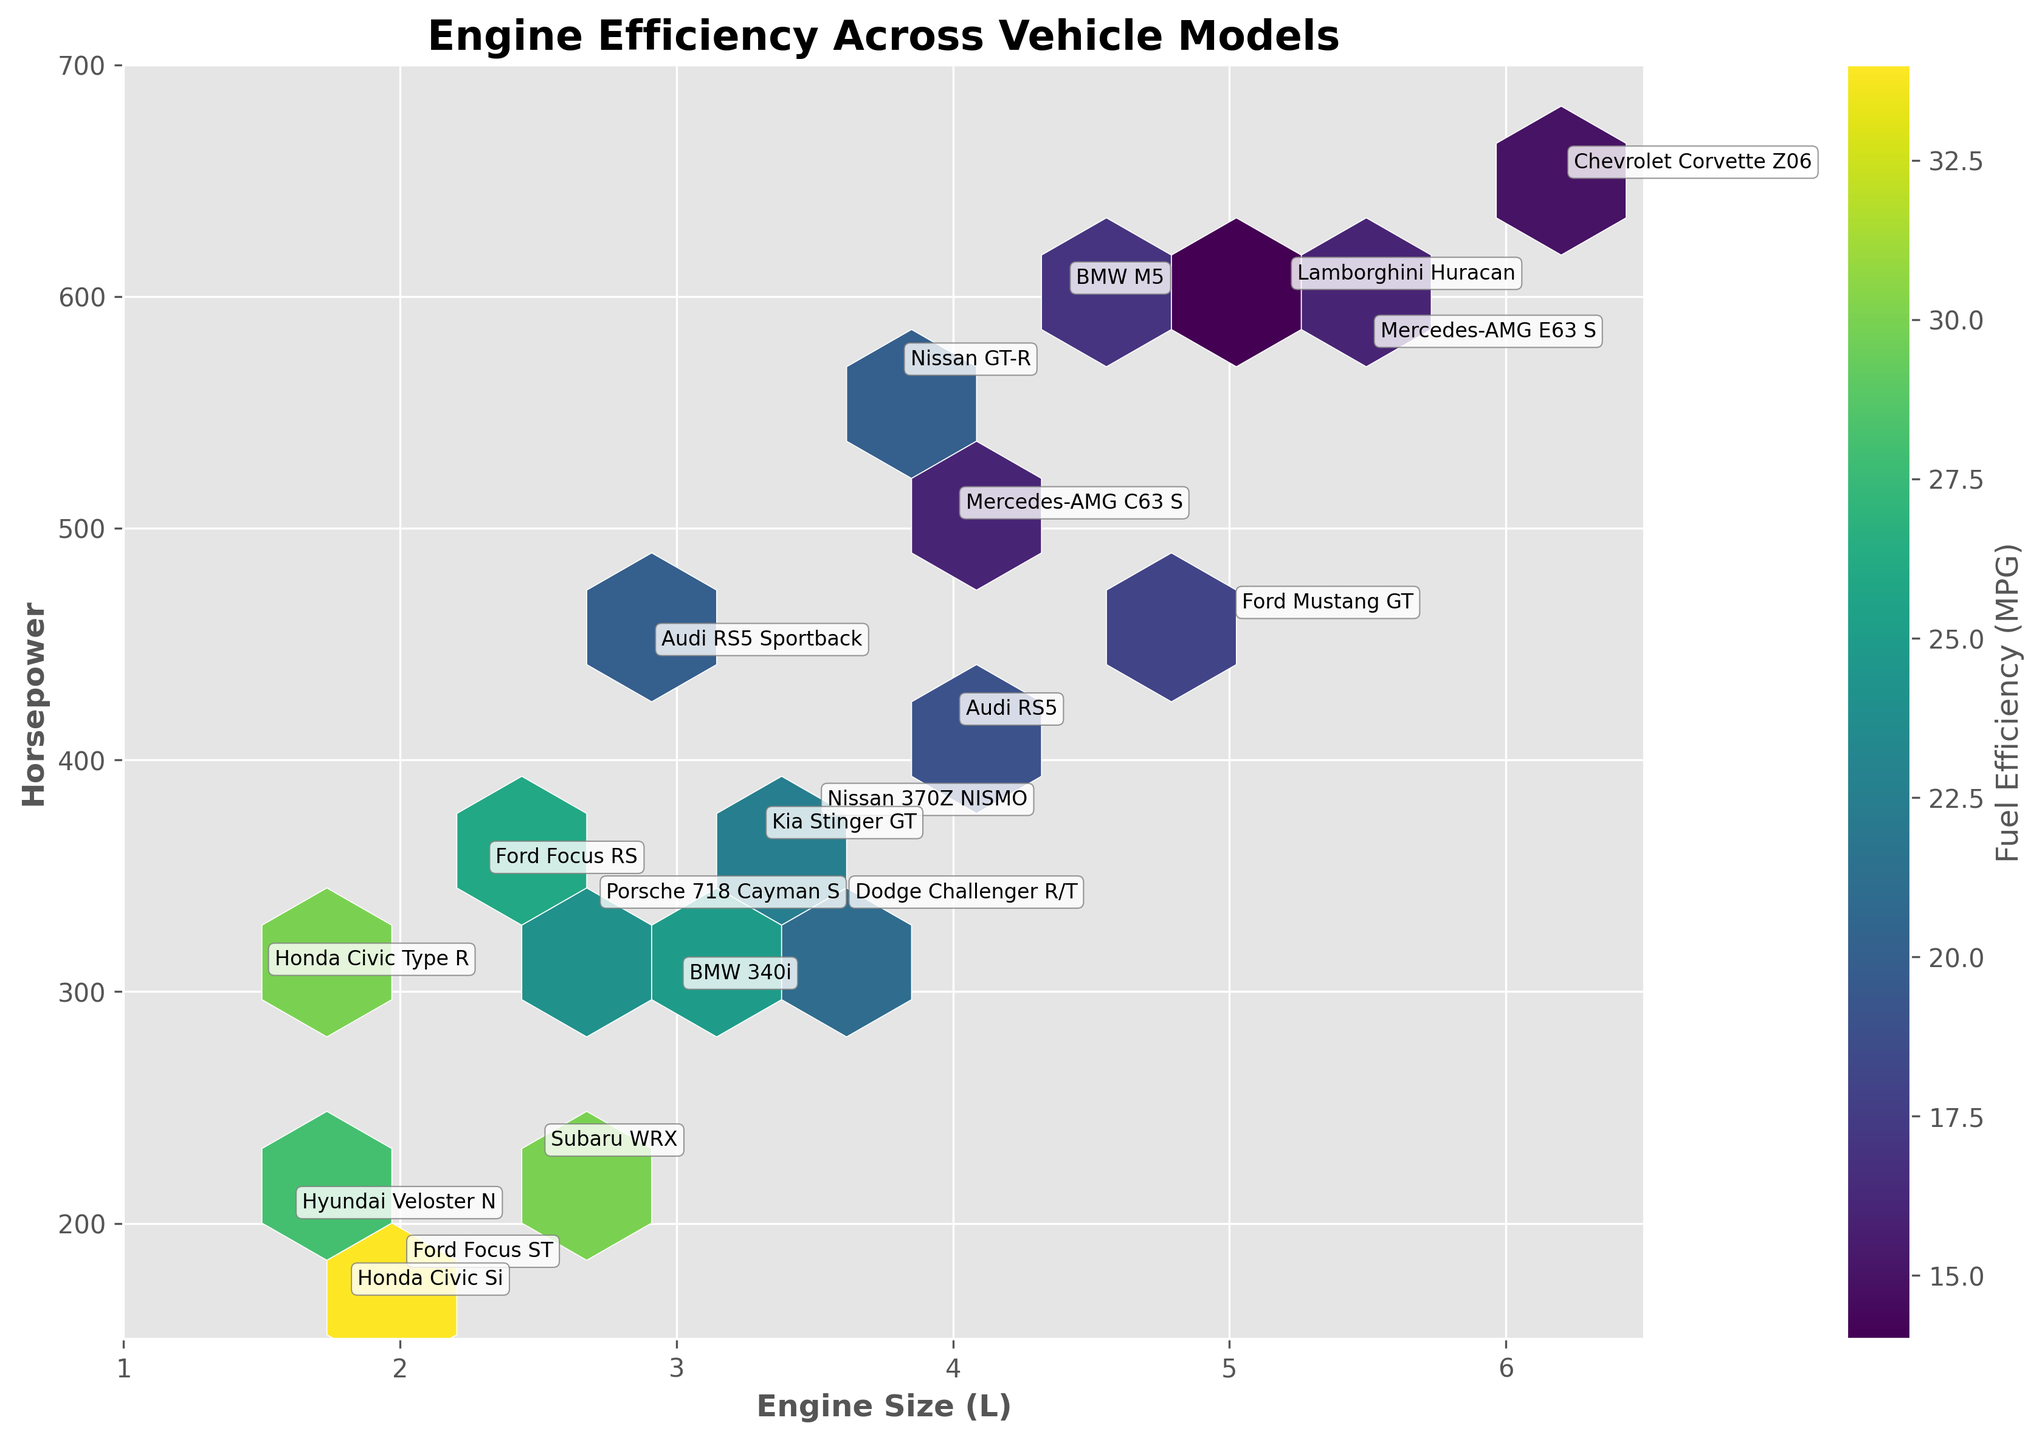What is the title of the hexbin plot? The title of the plot is shown at the top center of the figure.
Answer: Engine Efficiency Across Vehicle Models How many axes labels are shown and what are they? The x-axis label is "Engine Size (L)" and the y-axis label is "Horsepower."
Answer: Two labels: Engine Size (L) and Horsepower What is the color scale representing in this plot? The color scale represents "Fuel Efficiency (MPG)" as indicated by the color bar next to the plot.
Answer: Fuel Efficiency (MPG) Which vehicle model has the highest horsepower? By checking the y-axis values and the annotations, "Chevrolet Corvette Z06" has the highest horsepower of 650.
Answer: Chevrolet Corvette Z06 What range does the engine size cover on the x-axis? The x-axis starts at 1 and ends at 6.5 as indicated by the axis limits.
Answer: 1 to 6.5 What is the fuel efficiency of the BMW M5, and what engine size and horsepower does it have? Find the annotation for BMW M5 and use the axes and color scale to determine its metrics: Engine size is 4.4L, horsepower is 600, fuel efficiency is 17 MPG.
Answer: Engine Size: 4.4L, Horsepower: 600, Fuel Efficiency: 17 MPG Which car model has the smallest engine size and what is its fuel efficiency? By looking at the x-axis and annotations, "Honda Civic Type R" has the smallest engine size of 1.5L and a fuel efficiency of 30 MPG.
Answer: Honda Civic Type R, Fuel Efficiency: 30 MPG Compare the fuel efficiency between the Hyundai Veloster N and the Nissan 370Z NISMO. Check the hexagons where each model is placed and compare color depths; Hyundai Veloster N (Eng. Size: 1.6L, Horsepower: 201) has a fuel efficiency of 28 MPG, while Nissan 370Z NISMO (Eng. Size: 3.5L, Horsepower: 375) has a fuel efficiency of 22 MPG.
Answer: Hyundai Veloster N: 28 MPG, Nissan 370Z NISMO: 22 MPG Determine the average fuel efficiency of the models with engine sizes between 3.0L and 4.0L. Identify models within the range and sum their fuel efficiencies and divide by the number of models: BMW 340i (25), Nissan GT-R (20), Porsche 718 Cayman S (24), Audi RS5 (19). Average = (25+20+24+19)/4 = 22 MPG.
Answer: 22 MPG Which vehicle has higher horsepower: the Ford Focus ST or the Subaru WRX? Compare the y-axis values for the annotations: Ford Focus ST's horsepower is 180, while Subaru WRX's horsepower is 228.
Answer: Subaru WRX 